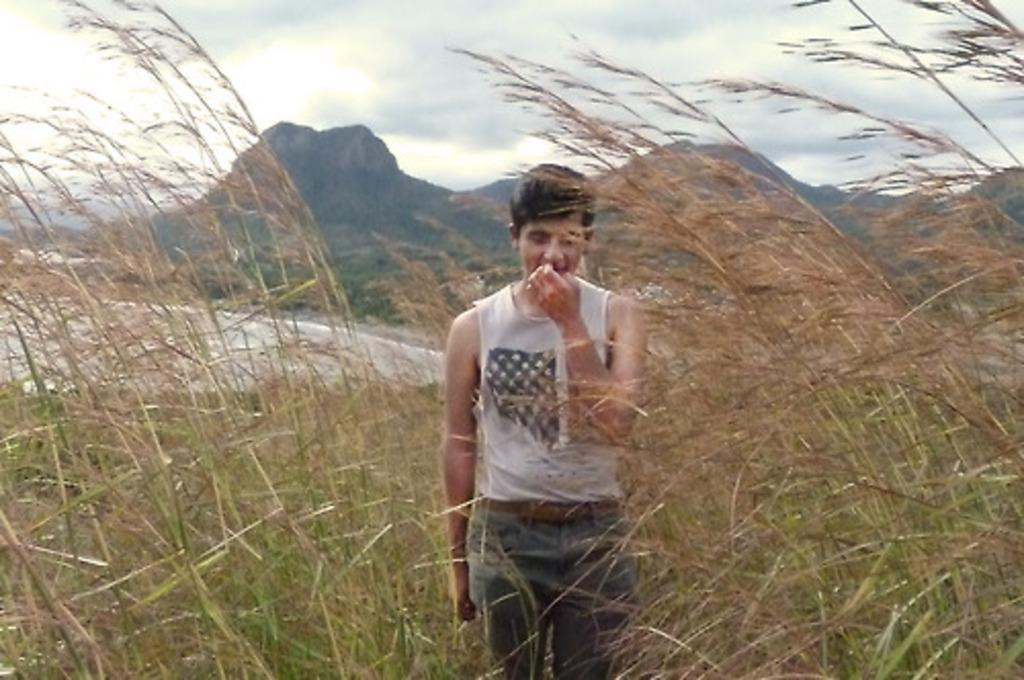What is the main subject of the image? There is a person standing in the image. What is the person standing on? The person is standing on a surface. What type of vegetation can be seen in the image? There is green grass visible in the image. What natural feature can be seen in the image? There is water visible in the image. What type of landscape is visible in the image? There are hills visible in the image. What is visible in the sky in the image? Clouds are present in the sky in the image. What type of metal is the soap made of in the image? There is no soap or metal present in the image. What type of crook is visible in the image? There is no crook present in the image. 